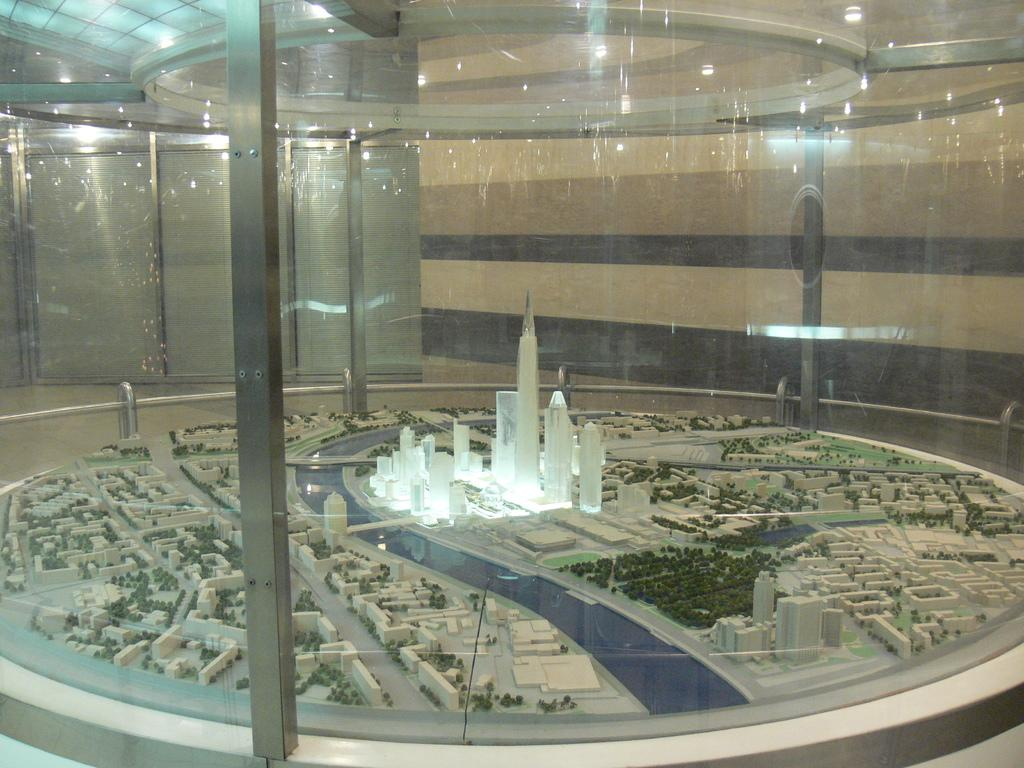What type of structures are present in the image? There are miniature buildings in the image. What other objects can be seen in the image? There are miniature trees in the image. What is visible on the ceiling in the background of the image? There are lights on the ceiling in the background of the image. What object is located in the front of the image? There is a glass in the front of the image. What type of haircut is the miniature building sporting in the image? The miniature buildings do not have haircuts, as they are inanimate objects. 